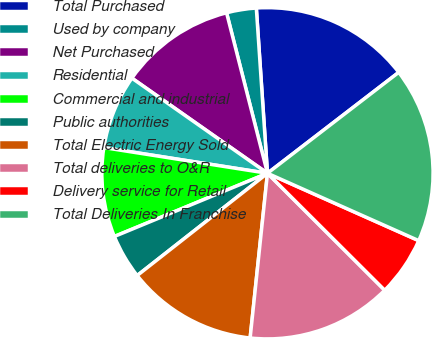Convert chart to OTSL. <chart><loc_0><loc_0><loc_500><loc_500><pie_chart><fcel>Total Purchased<fcel>Used by company<fcel>Net Purchased<fcel>Residential<fcel>Commercial and industrial<fcel>Public authorities<fcel>Total Electric Energy Sold<fcel>Total deliveries to O&R<fcel>Delivery service for Retail<fcel>Total Deliveries In Franchise<nl><fcel>15.64%<fcel>2.9%<fcel>11.29%<fcel>7.26%<fcel>8.71%<fcel>4.36%<fcel>12.74%<fcel>14.19%<fcel>5.81%<fcel>17.1%<nl></chart> 